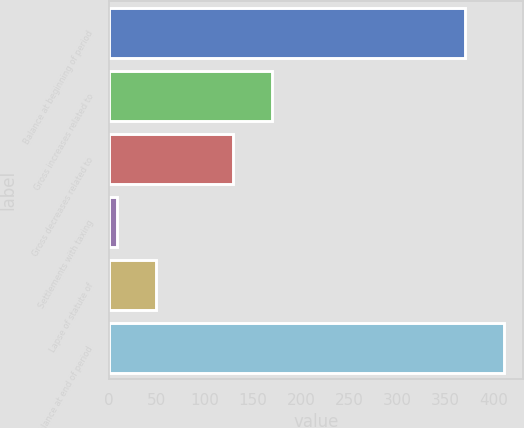Convert chart to OTSL. <chart><loc_0><loc_0><loc_500><loc_500><bar_chart><fcel>Balance at beginning of period<fcel>Gross increases related to<fcel>Gross decreases related to<fcel>Settlements with taxing<fcel>Lapse of statute of<fcel>Balance at end of period<nl><fcel>370<fcel>169.4<fcel>129.3<fcel>9<fcel>49.1<fcel>410.1<nl></chart> 